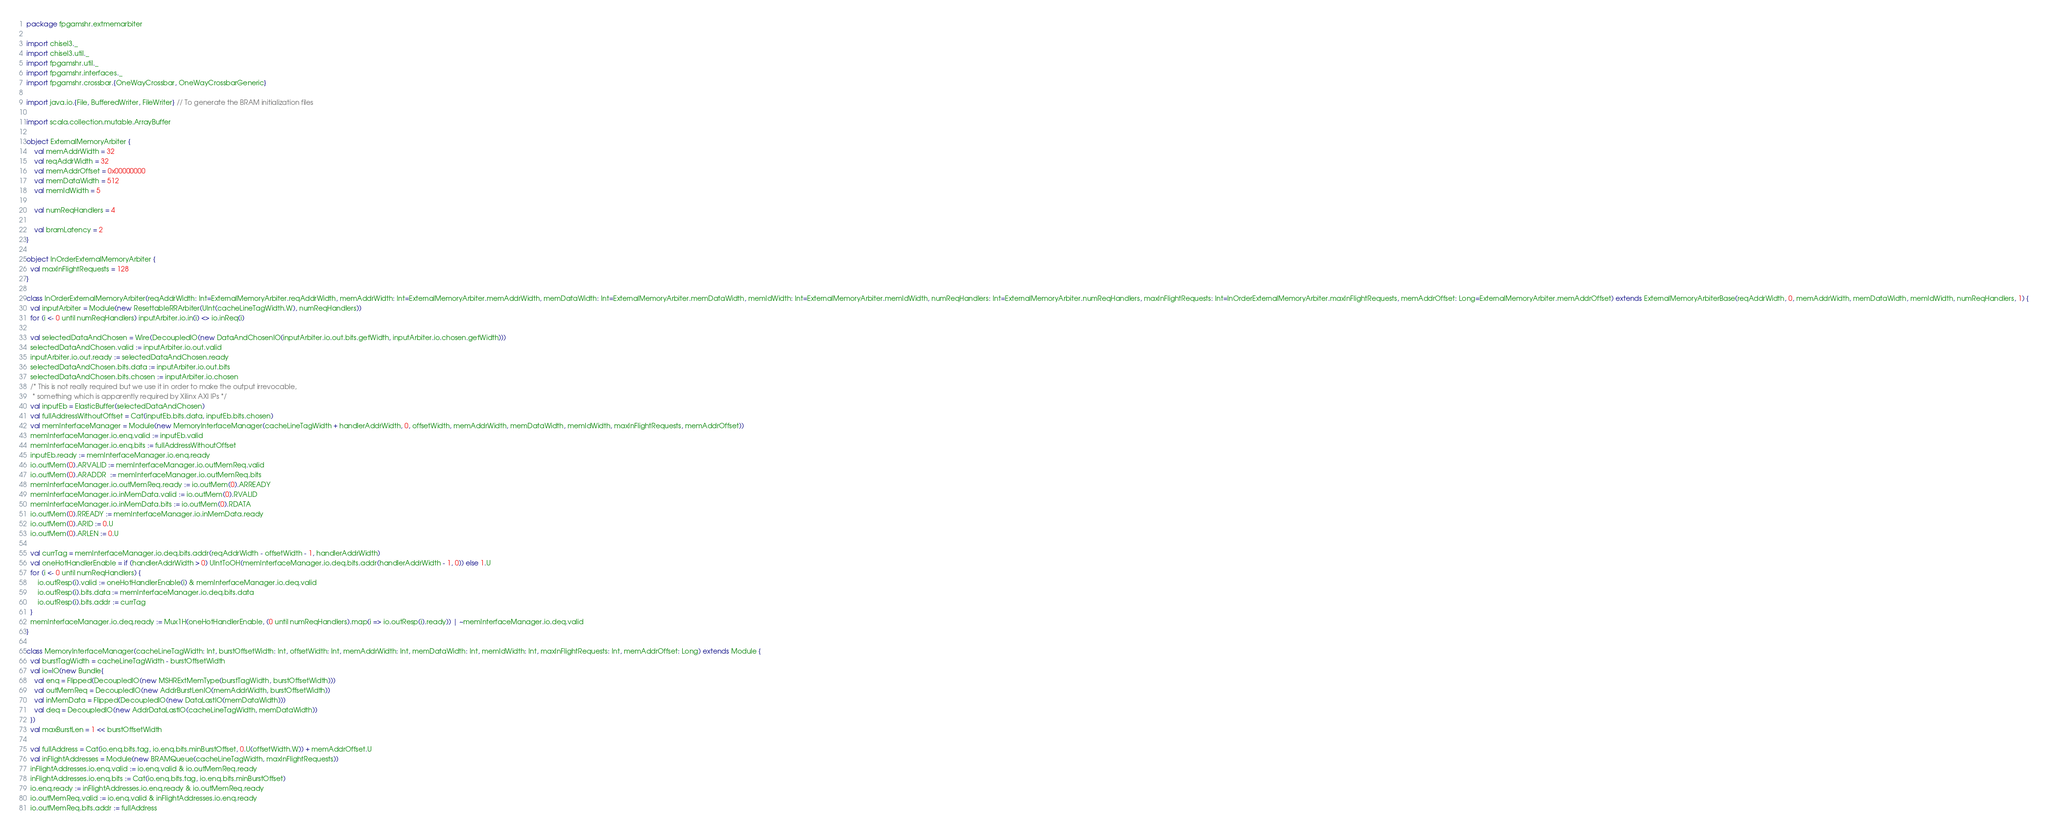<code> <loc_0><loc_0><loc_500><loc_500><_Scala_>package fpgamshr.extmemarbiter

import chisel3._
import chisel3.util._
import fpgamshr.util._
import fpgamshr.interfaces._
import fpgamshr.crossbar.{OneWayCrossbar, OneWayCrossbarGeneric}

import java.io.{File, BufferedWriter, FileWriter} // To generate the BRAM initialization files

import scala.collection.mutable.ArrayBuffer

object ExternalMemoryArbiter {
    val memAddrWidth = 32
    val reqAddrWidth = 32
    val memAddrOffset = 0x00000000
    val memDataWidth = 512
    val memIdWidth = 5

    val numReqHandlers = 4

    val bramLatency = 2
}

object InOrderExternalMemoryArbiter {
  val maxInFlightRequests = 128
}

class InOrderExternalMemoryArbiter(reqAddrWidth: Int=ExternalMemoryArbiter.reqAddrWidth, memAddrWidth: Int=ExternalMemoryArbiter.memAddrWidth, memDataWidth: Int=ExternalMemoryArbiter.memDataWidth, memIdWidth: Int=ExternalMemoryArbiter.memIdWidth, numReqHandlers: Int=ExternalMemoryArbiter.numReqHandlers, maxInFlightRequests: Int=InOrderExternalMemoryArbiter.maxInFlightRequests, memAddrOffset: Long=ExternalMemoryArbiter.memAddrOffset) extends ExternalMemoryArbiterBase(reqAddrWidth, 0, memAddrWidth, memDataWidth, memIdWidth, numReqHandlers, 1) {
  val inputArbiter = Module(new ResettableRRArbiter(UInt(cacheLineTagWidth.W), numReqHandlers))
  for (i <- 0 until numReqHandlers) inputArbiter.io.in(i) <> io.inReq(i)

  val selectedDataAndChosen = Wire(DecoupledIO(new DataAndChosenIO(inputArbiter.io.out.bits.getWidth, inputArbiter.io.chosen.getWidth)))
  selectedDataAndChosen.valid := inputArbiter.io.out.valid
  inputArbiter.io.out.ready := selectedDataAndChosen.ready
  selectedDataAndChosen.bits.data := inputArbiter.io.out.bits
  selectedDataAndChosen.bits.chosen := inputArbiter.io.chosen
  /* This is not really required but we use it in order to make the output irrevocable,
   * something which is apparently required by Xilinx AXI IPs */
  val inputEb = ElasticBuffer(selectedDataAndChosen)
  val fullAddressWithoutOffset = Cat(inputEb.bits.data, inputEb.bits.chosen)
  val memInterfaceManager = Module(new MemoryInterfaceManager(cacheLineTagWidth + handlerAddrWidth, 0, offsetWidth, memAddrWidth, memDataWidth, memIdWidth, maxInFlightRequests, memAddrOffset))
  memInterfaceManager.io.enq.valid := inputEb.valid
  memInterfaceManager.io.enq.bits := fullAddressWithoutOffset
  inputEb.ready := memInterfaceManager.io.enq.ready
  io.outMem(0).ARVALID := memInterfaceManager.io.outMemReq.valid
  io.outMem(0).ARADDR  := memInterfaceManager.io.outMemReq.bits
  memInterfaceManager.io.outMemReq.ready := io.outMem(0).ARREADY
  memInterfaceManager.io.inMemData.valid := io.outMem(0).RVALID
  memInterfaceManager.io.inMemData.bits := io.outMem(0).RDATA
  io.outMem(0).RREADY := memInterfaceManager.io.inMemData.ready
  io.outMem(0).ARID := 0.U
  io.outMem(0).ARLEN := 0.U

  val currTag = memInterfaceManager.io.deq.bits.addr(reqAddrWidth - offsetWidth - 1, handlerAddrWidth)
  val oneHotHandlerEnable = if (handlerAddrWidth > 0) UIntToOH(memInterfaceManager.io.deq.bits.addr(handlerAddrWidth - 1, 0)) else 1.U
  for (i <- 0 until numReqHandlers) {
      io.outResp(i).valid := oneHotHandlerEnable(i) & memInterfaceManager.io.deq.valid
      io.outResp(i).bits.data := memInterfaceManager.io.deq.bits.data
      io.outResp(i).bits.addr := currTag
  }
  memInterfaceManager.io.deq.ready := Mux1H(oneHotHandlerEnable, (0 until numReqHandlers).map(i => io.outResp(i).ready)) | ~memInterfaceManager.io.deq.valid
}

class MemoryInterfaceManager(cacheLineTagWidth: Int, burstOffsetWidth: Int, offsetWidth: Int, memAddrWidth: Int, memDataWidth: Int, memIdWidth: Int, maxInFlightRequests: Int, memAddrOffset: Long) extends Module {
  val burstTagWidth = cacheLineTagWidth - burstOffsetWidth
  val io=IO(new Bundle{
    val enq = Flipped(DecoupledIO(new MSHRExtMemType(burstTagWidth, burstOffsetWidth)))
    val outMemReq = DecoupledIO(new AddrBurstLenIO(memAddrWidth, burstOffsetWidth))
    val inMemData = Flipped(DecoupledIO(new DataLastIO(memDataWidth)))
    val deq = DecoupledIO(new AddrDataLastIO(cacheLineTagWidth, memDataWidth))
  })
  val maxBurstLen = 1 << burstOffsetWidth

  val fullAddress = Cat(io.enq.bits.tag, io.enq.bits.minBurstOffset, 0.U(offsetWidth.W)) + memAddrOffset.U
  val inFlightAddresses = Module(new BRAMQueue(cacheLineTagWidth, maxInFlightRequests))
  inFlightAddresses.io.enq.valid := io.enq.valid & io.outMemReq.ready
  inFlightAddresses.io.enq.bits := Cat(io.enq.bits.tag, io.enq.bits.minBurstOffset)
  io.enq.ready := inFlightAddresses.io.enq.ready & io.outMemReq.ready
  io.outMemReq.valid := io.enq.valid & inFlightAddresses.io.enq.ready
  io.outMemReq.bits.addr := fullAddress</code> 